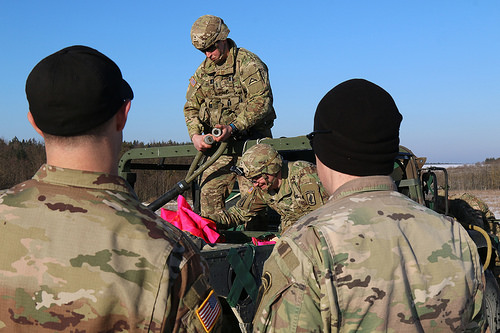<image>
Is there a helmet on the soldier? No. The helmet is not positioned on the soldier. They may be near each other, but the helmet is not supported by or resting on top of the soldier. 